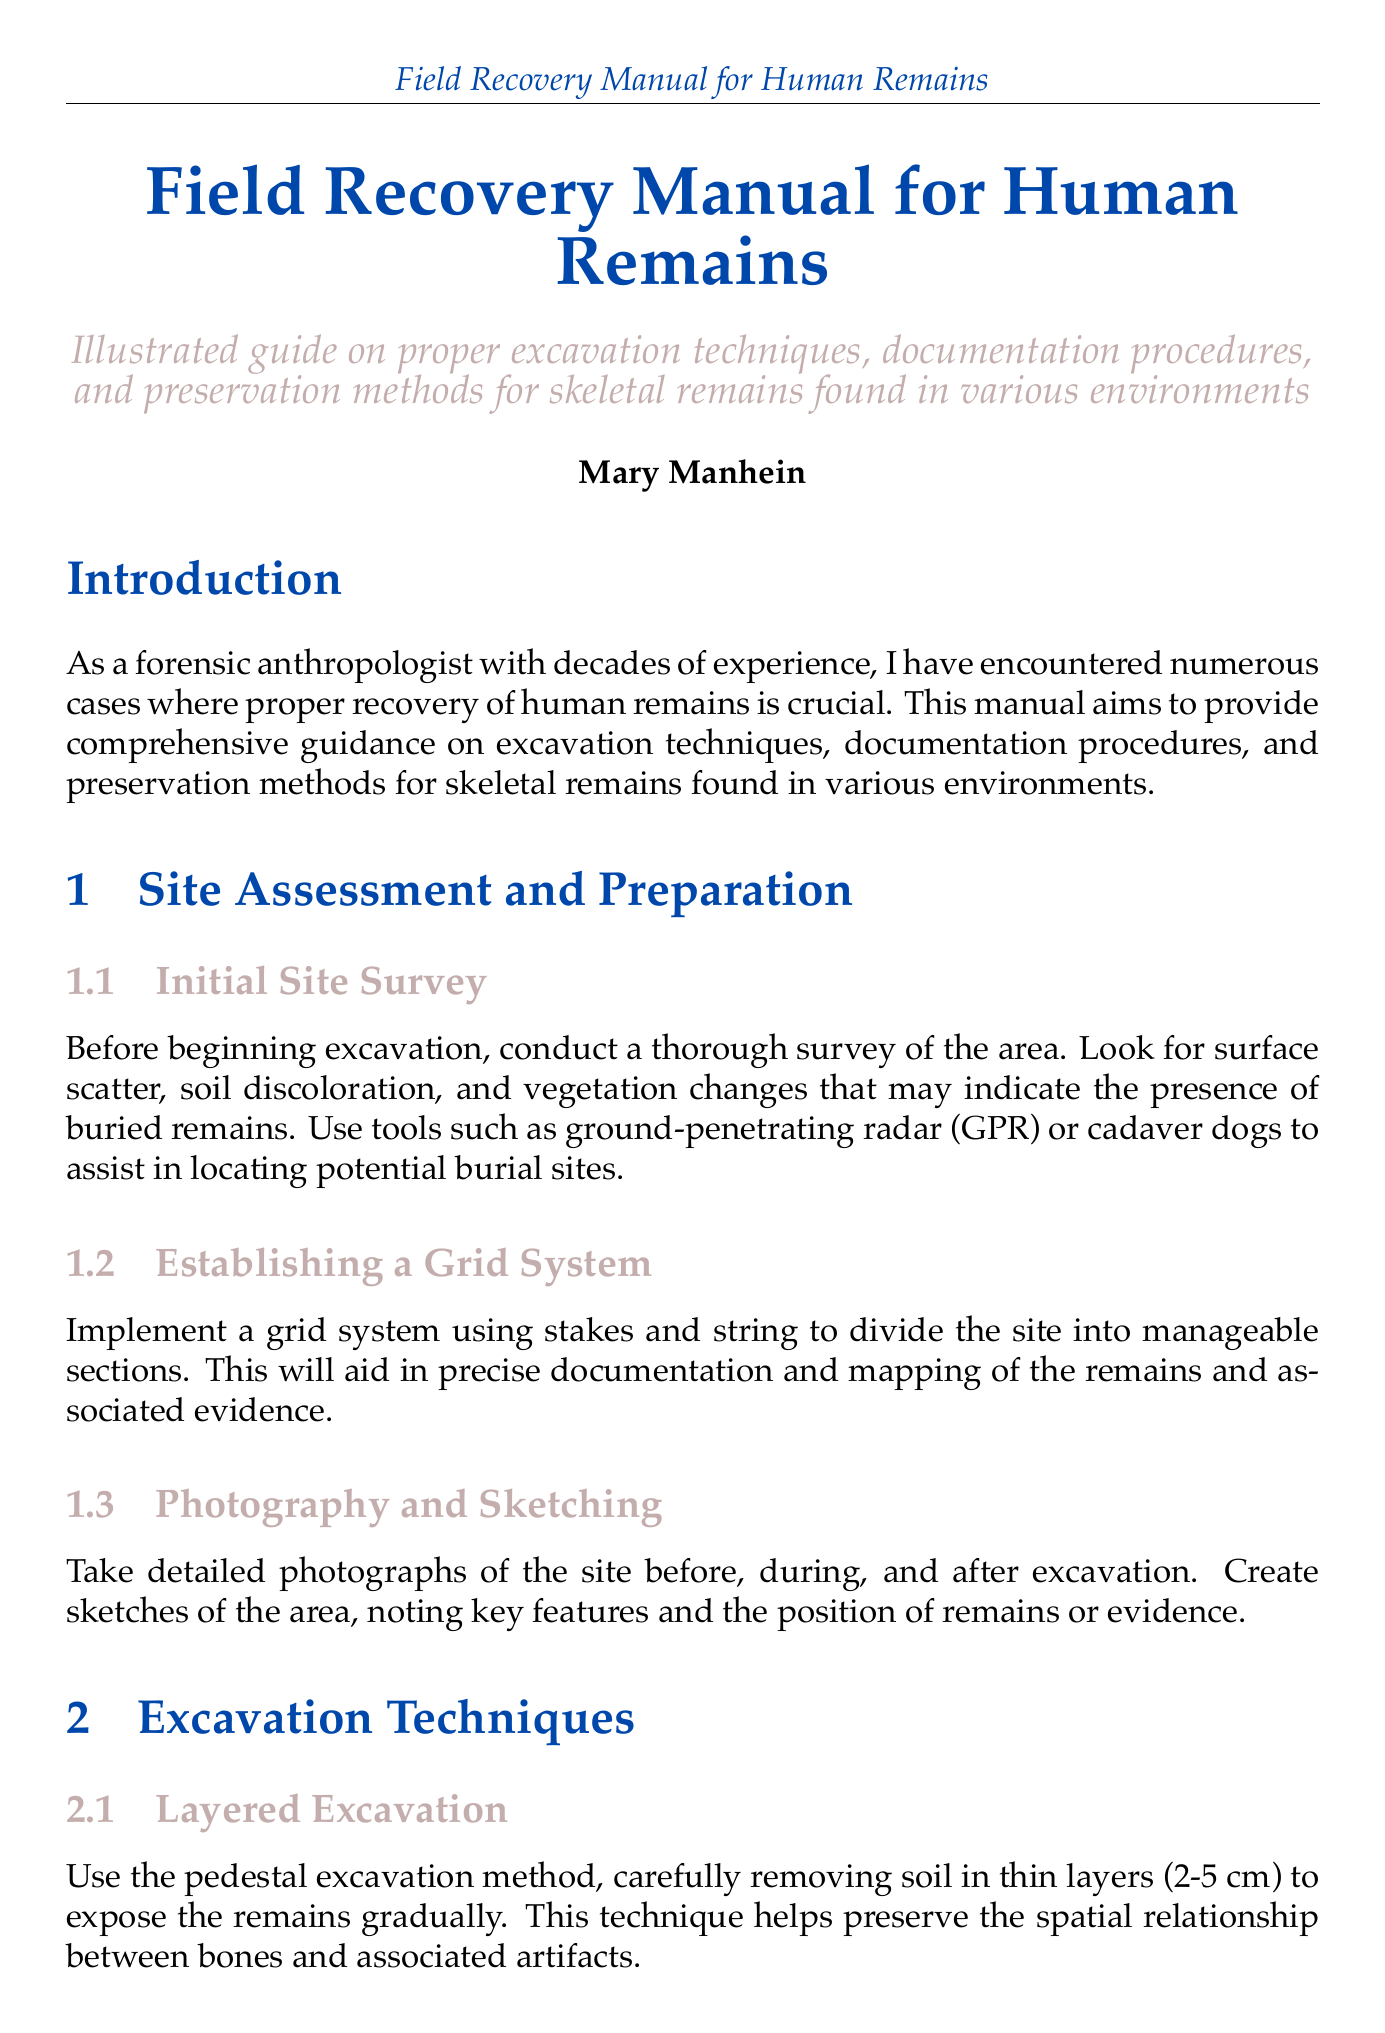What is the title of the manual? The title of the manual is explicitly stated at the beginning of the document.
Answer: Field Recovery Manual for Human Remains Who is the author of the manual? The author of the manual is mentioned in the introduction section.
Answer: Mary Manhein What technique is used for layered excavation? The method recommended for layered excavation is outlined in the excavation techniques section.
Answer: Pedestal excavation What tools should be used for delicate work around bones? The document specifies appropriate tools for excavation work in the tool selection subsection.
Answer: Soft-bristled brushes What is the recommended storage temperature for remains? The ideal storage temperature is detailed in the environmental control subsection.
Answer: 18-20°C Which equipment is suggested for underwater recovery? The specialized equipment for underwater recovery is mentioned under the corresponding subsection.
Answer: Suction dredges What should be done to prevent further degradation of fragile bones? The preservation method for fragile bones is specified in the stabilization subsection.
Answer: Apply consolidants What should be used to wrap individual bones? The packaging guidelines for bones are provided in the preservation methods section.
Answer: Acid-free tissue paper What technique is used for creating 3D models of the site? The documentation technique for creating 3D models is mentioned in the photogrammetry subsection.
Answer: Photogrammetry 